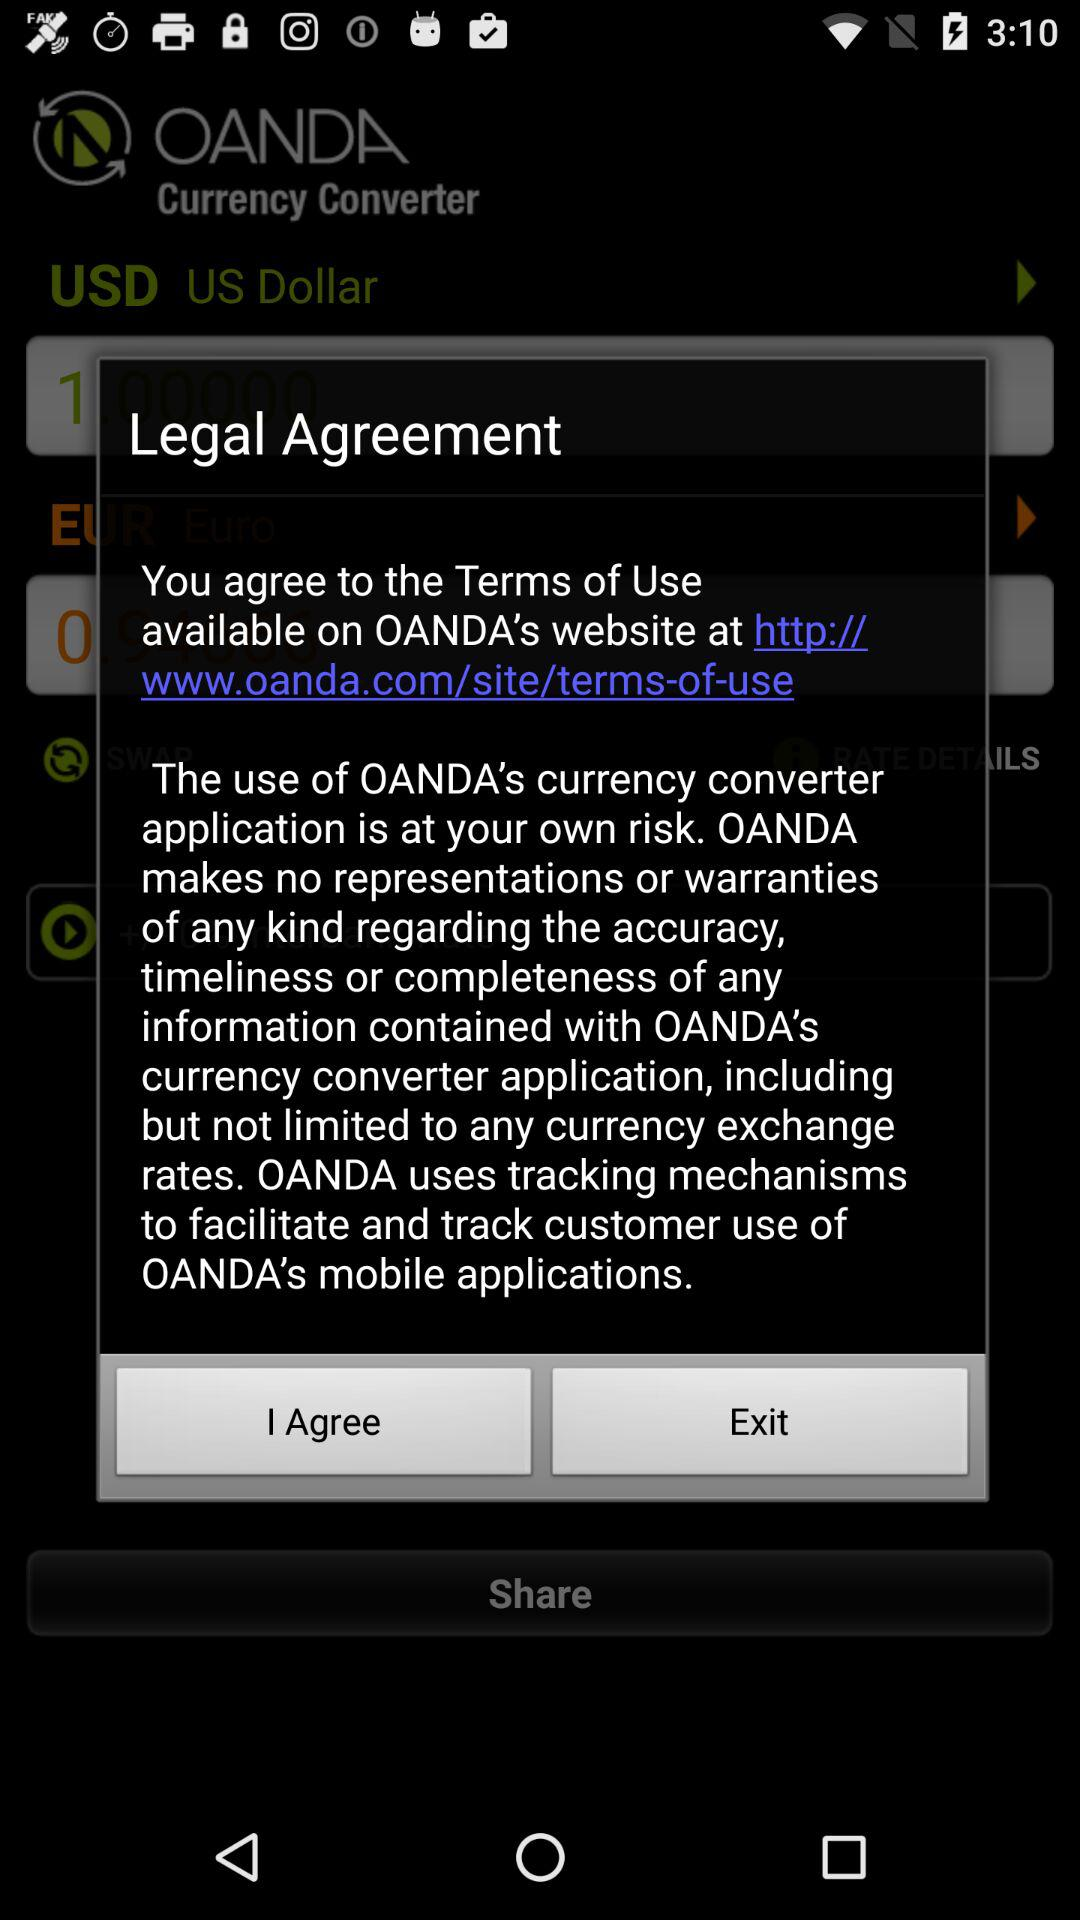What is the website where the Terms of Use are available? The website is http://www.oanda.com/site/terms-of-use. 